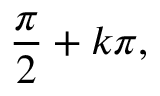Convert formula to latex. <formula><loc_0><loc_0><loc_500><loc_500>{ \frac { \pi } { 2 } } + k \pi ,</formula> 